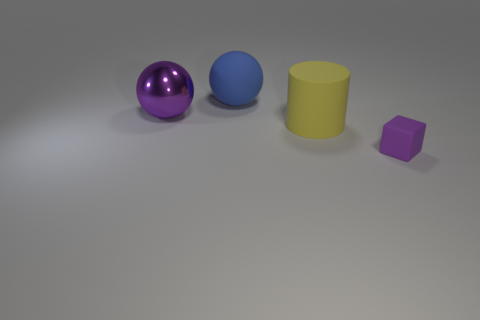Add 4 purple rubber cubes. How many objects exist? 8 Subtract 1 balls. How many balls are left? 1 Subtract all cubes. How many objects are left? 3 Add 3 blue shiny cubes. How many blue shiny cubes exist? 3 Subtract all blue balls. How many balls are left? 1 Subtract 1 yellow cylinders. How many objects are left? 3 Subtract all red balls. Subtract all gray cubes. How many balls are left? 2 Subtract all cyan cylinders. How many purple balls are left? 1 Subtract all tiny rubber blocks. Subtract all purple metallic things. How many objects are left? 2 Add 1 tiny purple blocks. How many tiny purple blocks are left? 2 